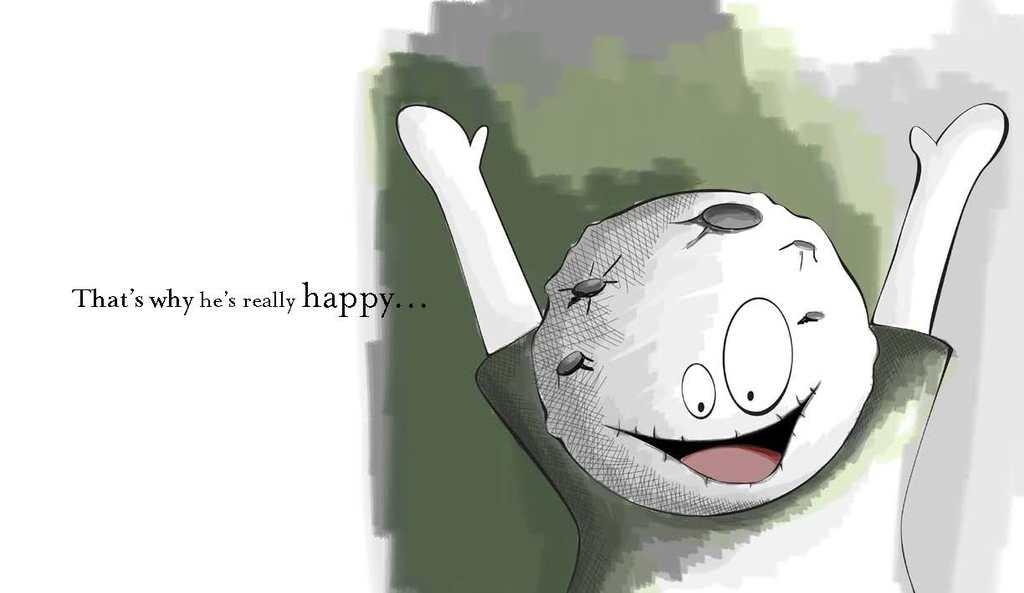What is depicted in the image as the main subject? There is a cartoon of a boy in the image. What type of natural elements can be seen in the image? There are trees on the right side of the image. Where is the text located in the image? The text is on the left side of the image. What type of voice can be heard coming from the boy in the image? There is no sound or voice present in the image, as it is a static cartoon. What type of plant is growing on the boy's head in the image? There is no plant growing on the boy's head in the image; he is depicted as a cartoon character without any plant elements. 